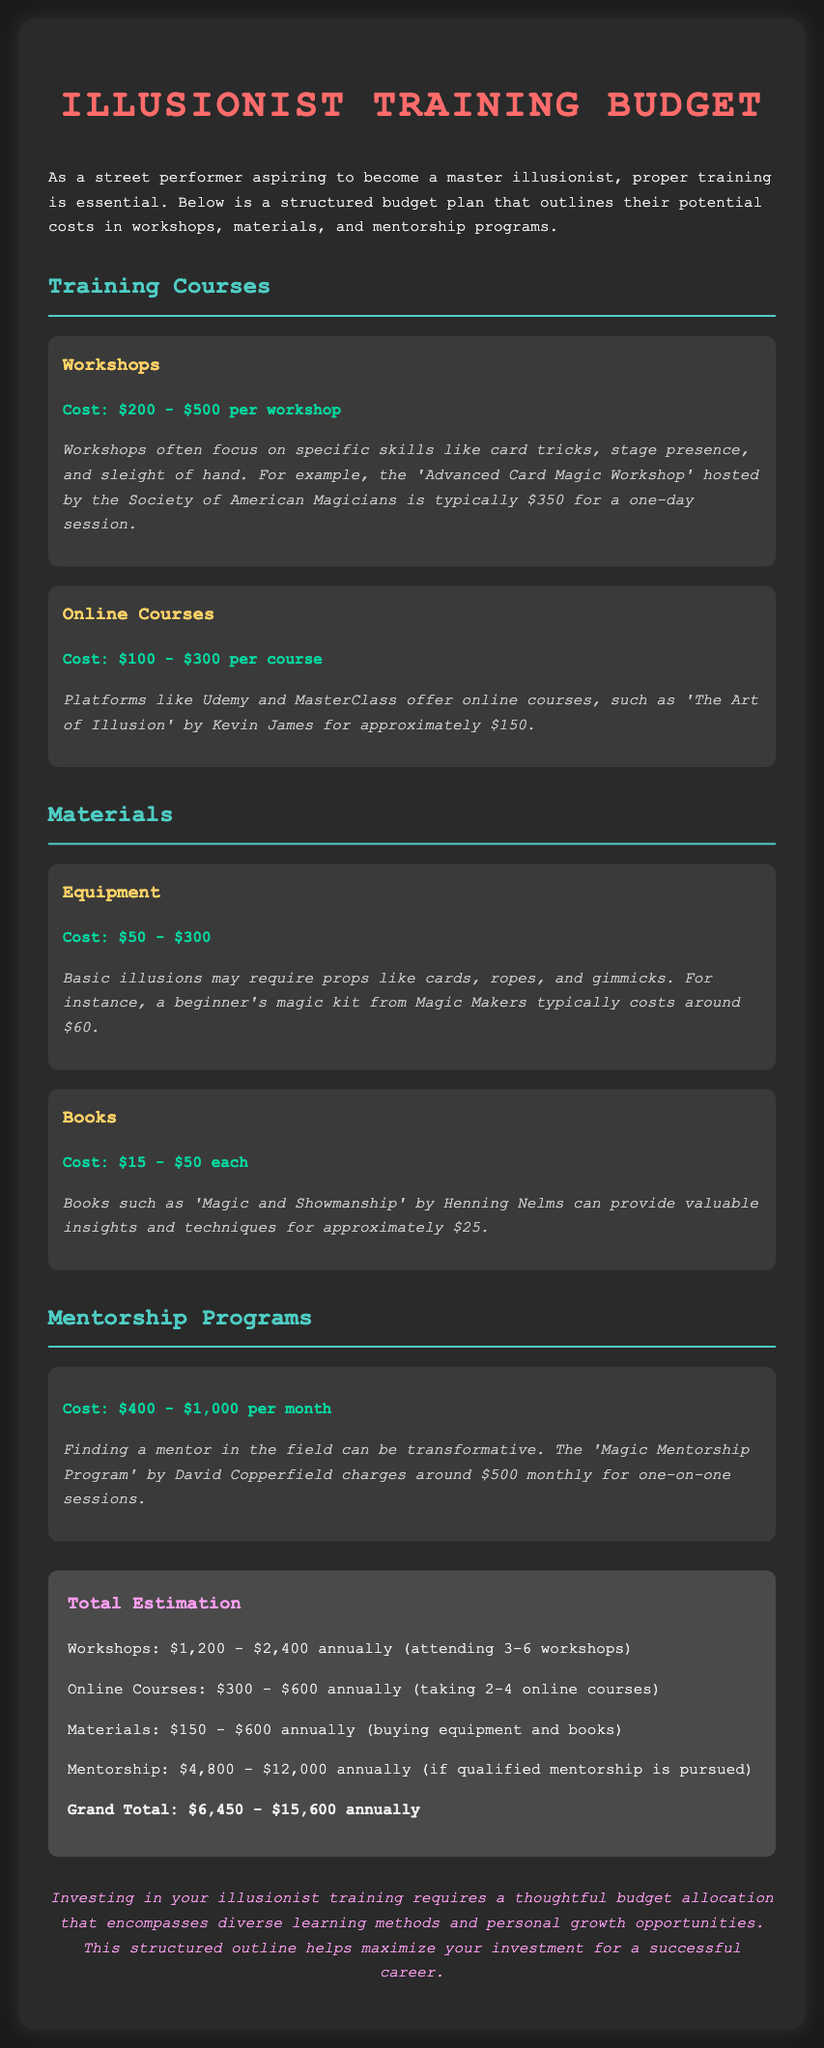what is the cost range for workshops? The document specifies that workshops cost between $200 and $500 each.
Answer: $200 - $500 what is the typical cost of an online course? According to the document, online courses typically cost around $100 to $300 each.
Answer: $100 - $300 how much can mentorship programs cost per month? The document indicates that mentorship programs cost between $400 and $1,000 per month.
Answer: $400 - $1,000 what is the estimated annual cost for attending 3-6 workshops? The total estimation states the annual cost for attending 3-6 workshops is $1,200 to $2,400.
Answer: $1,200 - $2,400 which book is mentioned in the document? The document mentions 'Magic and Showmanship' by Henning Nelms as a valuable resource.
Answer: 'Magic and Showmanship' what is the grand total estimation for all expenses? The grand total estimation provided in the document is the sum of all educational investments ranging from $6,450 to $15,600 annually.
Answer: $6,450 - $15,600 how much might a beginner's magic kit cost? The document notes that a beginner's magic kit from Magic Makers typically costs around $60.
Answer: $60 which workshop is specifically mentioned by name? The document specifically mentions the 'Advanced Card Magic Workshop' hosted by the Society of American Magicians.
Answer: 'Advanced Card Magic Workshop' what is the cost range for books? Books are stated to cost between $15 and $50 each according to the document.
Answer: $15 - $50 